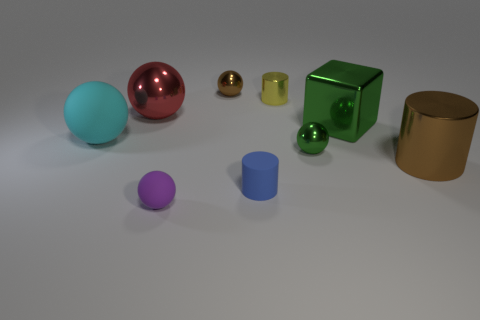What size is the purple thing that is the same shape as the small green object?
Your answer should be very brief. Small. What is the material of the sphere right of the small brown thing to the right of the tiny purple sphere?
Keep it short and to the point. Metal. Do the red metallic thing and the large cyan thing have the same shape?
Your answer should be compact. Yes. How many things are both right of the large cyan matte sphere and left of the small brown ball?
Ensure brevity in your answer.  2. Is the number of large metal objects that are on the right side of the red sphere the same as the number of objects in front of the large brown object?
Offer a very short reply. Yes. There is a brown metal thing that is to the left of the small green thing; is its size the same as the shiny cylinder that is right of the green block?
Offer a terse response. No. What is the small ball that is right of the purple matte sphere and in front of the shiny cube made of?
Provide a short and direct response. Metal. Is the number of large gray objects less than the number of tiny yellow cylinders?
Keep it short and to the point. Yes. There is a rubber object that is on the right side of the rubber thing in front of the blue thing; what is its size?
Give a very brief answer. Small. There is a large cyan matte thing behind the brown metal object in front of the small shiny ball behind the large matte thing; what shape is it?
Give a very brief answer. Sphere. 